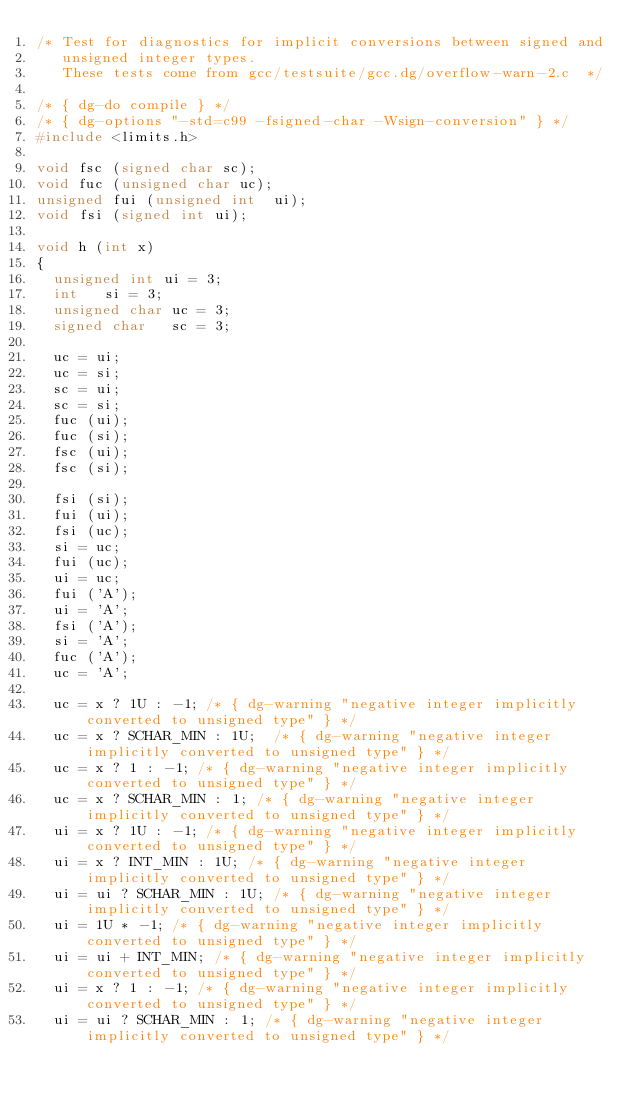Convert code to text. <code><loc_0><loc_0><loc_500><loc_500><_C_>/* Test for diagnostics for implicit conversions between signed and
   unsigned integer types.
   These tests come from gcc/testsuite/gcc.dg/overflow-warn-2.c  */

/* { dg-do compile } */
/* { dg-options "-std=c99 -fsigned-char -Wsign-conversion" } */
#include <limits.h>

void fsc (signed char sc);
void fuc (unsigned char uc);
unsigned fui (unsigned int  ui);
void fsi (signed int ui);

void h (int x)
{
  unsigned int ui = 3;
  int   si = 3;
  unsigned char uc = 3;
  signed char   sc = 3;

  uc = ui; 
  uc = si; 
  sc = ui; 
  sc = si; 
  fuc (ui);
  fuc (si);
  fsc (ui);
  fsc (si);

  fsi (si);
  fui (ui);
  fsi (uc);
  si = uc;
  fui (uc);
  ui = uc;
  fui ('A');
  ui = 'A';
  fsi ('A');
  si = 'A';
  fuc ('A');
  uc = 'A';

  uc = x ? 1U : -1; /* { dg-warning "negative integer implicitly converted to unsigned type" } */
  uc = x ? SCHAR_MIN : 1U;  /* { dg-warning "negative integer implicitly converted to unsigned type" } */
  uc = x ? 1 : -1; /* { dg-warning "negative integer implicitly converted to unsigned type" } */
  uc = x ? SCHAR_MIN : 1; /* { dg-warning "negative integer implicitly converted to unsigned type" } */
  ui = x ? 1U : -1; /* { dg-warning "negative integer implicitly converted to unsigned type" } */
  ui = x ? INT_MIN : 1U; /* { dg-warning "negative integer implicitly converted to unsigned type" } */
  ui = ui ? SCHAR_MIN : 1U; /* { dg-warning "negative integer implicitly converted to unsigned type" } */
  ui = 1U * -1; /* { dg-warning "negative integer implicitly converted to unsigned type" } */
  ui = ui + INT_MIN; /* { dg-warning "negative integer implicitly converted to unsigned type" } */
  ui = x ? 1 : -1; /* { dg-warning "negative integer implicitly converted to unsigned type" } */
  ui = ui ? SCHAR_MIN : 1; /* { dg-warning "negative integer implicitly converted to unsigned type" } */
</code> 